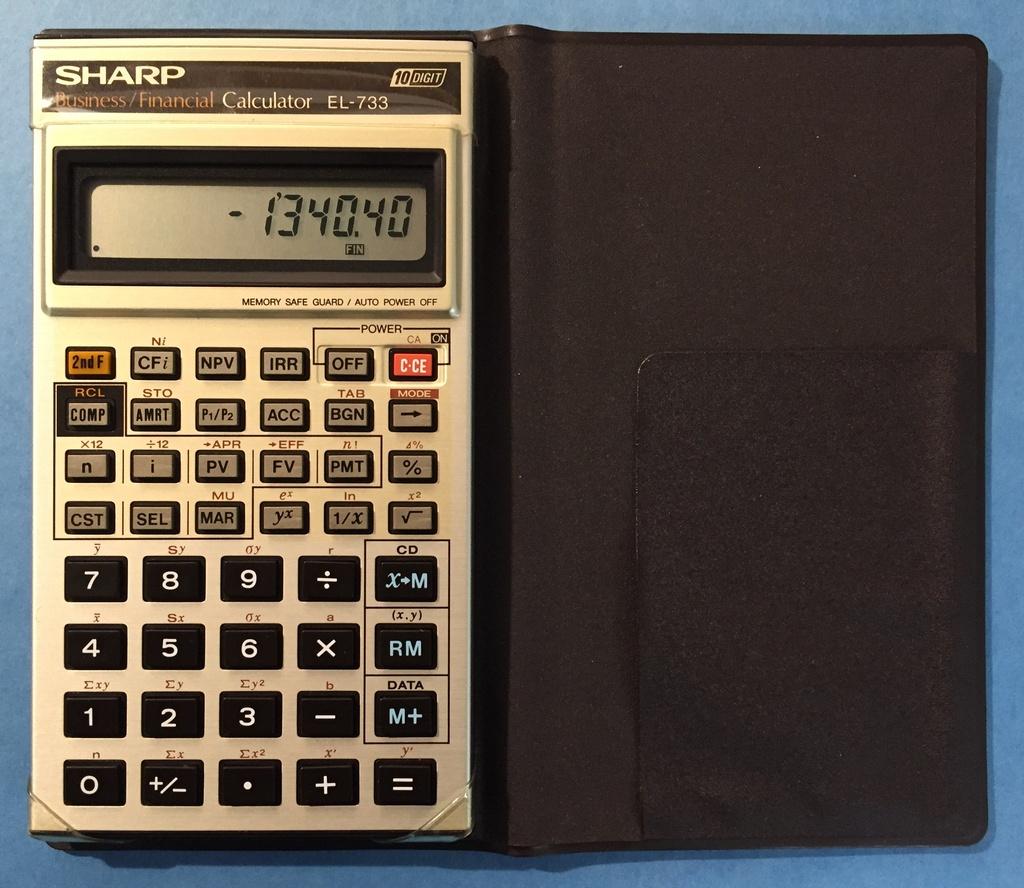What type of calculator is that?
Provide a succinct answer. Sharp. Does the calculator have a 0 button?
Provide a succinct answer. Yes. 